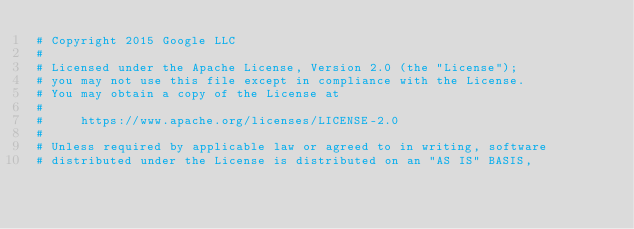<code> <loc_0><loc_0><loc_500><loc_500><_Ruby_># Copyright 2015 Google LLC
#
# Licensed under the Apache License, Version 2.0 (the "License");
# you may not use this file except in compliance with the License.
# You may obtain a copy of the License at
#
#     https://www.apache.org/licenses/LICENSE-2.0
#
# Unless required by applicable law or agreed to in writing, software
# distributed under the License is distributed on an "AS IS" BASIS,</code> 